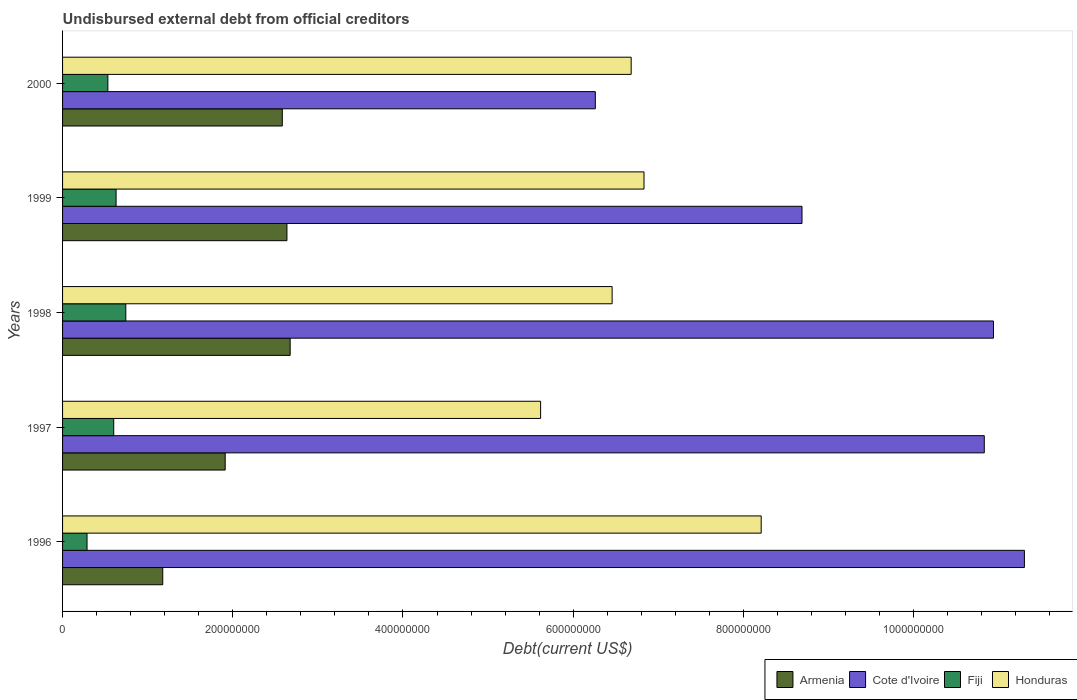Are the number of bars per tick equal to the number of legend labels?
Provide a succinct answer. Yes. Are the number of bars on each tick of the Y-axis equal?
Your answer should be very brief. Yes. How many bars are there on the 5th tick from the top?
Your answer should be compact. 4. How many bars are there on the 5th tick from the bottom?
Offer a terse response. 4. In how many cases, is the number of bars for a given year not equal to the number of legend labels?
Ensure brevity in your answer.  0. What is the total debt in Armenia in 2000?
Your response must be concise. 2.58e+08. Across all years, what is the maximum total debt in Cote d'Ivoire?
Your answer should be very brief. 1.13e+09. Across all years, what is the minimum total debt in Armenia?
Provide a succinct answer. 1.18e+08. In which year was the total debt in Honduras maximum?
Provide a short and direct response. 1996. What is the total total debt in Honduras in the graph?
Ensure brevity in your answer.  3.38e+09. What is the difference between the total debt in Armenia in 1998 and that in 1999?
Provide a succinct answer. 3.78e+06. What is the difference between the total debt in Fiji in 2000 and the total debt in Armenia in 1998?
Give a very brief answer. -2.14e+08. What is the average total debt in Armenia per year?
Your response must be concise. 2.20e+08. In the year 1998, what is the difference between the total debt in Honduras and total debt in Fiji?
Your answer should be very brief. 5.71e+08. In how many years, is the total debt in Cote d'Ivoire greater than 1080000000 US$?
Provide a succinct answer. 3. What is the ratio of the total debt in Armenia in 1997 to that in 1998?
Your answer should be compact. 0.71. Is the difference between the total debt in Honduras in 1997 and 1999 greater than the difference between the total debt in Fiji in 1997 and 1999?
Give a very brief answer. No. What is the difference between the highest and the second highest total debt in Honduras?
Keep it short and to the point. 1.38e+08. What is the difference between the highest and the lowest total debt in Cote d'Ivoire?
Provide a succinct answer. 5.04e+08. Is the sum of the total debt in Armenia in 1998 and 2000 greater than the maximum total debt in Cote d'Ivoire across all years?
Provide a short and direct response. No. What does the 1st bar from the top in 1999 represents?
Make the answer very short. Honduras. What does the 4th bar from the bottom in 1999 represents?
Provide a succinct answer. Honduras. Is it the case that in every year, the sum of the total debt in Fiji and total debt in Armenia is greater than the total debt in Honduras?
Offer a very short reply. No. How many years are there in the graph?
Provide a short and direct response. 5. Where does the legend appear in the graph?
Your answer should be very brief. Bottom right. How are the legend labels stacked?
Give a very brief answer. Horizontal. What is the title of the graph?
Your answer should be very brief. Undisbursed external debt from official creditors. What is the label or title of the X-axis?
Your answer should be compact. Debt(current US$). What is the Debt(current US$) in Armenia in 1996?
Your response must be concise. 1.18e+08. What is the Debt(current US$) in Cote d'Ivoire in 1996?
Your response must be concise. 1.13e+09. What is the Debt(current US$) of Fiji in 1996?
Your answer should be compact. 2.88e+07. What is the Debt(current US$) in Honduras in 1996?
Provide a short and direct response. 8.21e+08. What is the Debt(current US$) in Armenia in 1997?
Provide a short and direct response. 1.91e+08. What is the Debt(current US$) in Cote d'Ivoire in 1997?
Offer a terse response. 1.08e+09. What is the Debt(current US$) in Fiji in 1997?
Offer a very short reply. 6.01e+07. What is the Debt(current US$) of Honduras in 1997?
Offer a terse response. 5.62e+08. What is the Debt(current US$) of Armenia in 1998?
Provide a succinct answer. 2.67e+08. What is the Debt(current US$) of Cote d'Ivoire in 1998?
Your answer should be very brief. 1.09e+09. What is the Debt(current US$) of Fiji in 1998?
Make the answer very short. 7.43e+07. What is the Debt(current US$) of Honduras in 1998?
Provide a short and direct response. 6.46e+08. What is the Debt(current US$) in Armenia in 1999?
Your response must be concise. 2.64e+08. What is the Debt(current US$) in Cote d'Ivoire in 1999?
Ensure brevity in your answer.  8.69e+08. What is the Debt(current US$) in Fiji in 1999?
Your response must be concise. 6.29e+07. What is the Debt(current US$) in Honduras in 1999?
Ensure brevity in your answer.  6.83e+08. What is the Debt(current US$) of Armenia in 2000?
Offer a very short reply. 2.58e+08. What is the Debt(current US$) in Cote d'Ivoire in 2000?
Offer a terse response. 6.26e+08. What is the Debt(current US$) in Fiji in 2000?
Your answer should be very brief. 5.32e+07. What is the Debt(current US$) in Honduras in 2000?
Make the answer very short. 6.68e+08. Across all years, what is the maximum Debt(current US$) in Armenia?
Give a very brief answer. 2.67e+08. Across all years, what is the maximum Debt(current US$) in Cote d'Ivoire?
Provide a short and direct response. 1.13e+09. Across all years, what is the maximum Debt(current US$) of Fiji?
Ensure brevity in your answer.  7.43e+07. Across all years, what is the maximum Debt(current US$) of Honduras?
Your answer should be very brief. 8.21e+08. Across all years, what is the minimum Debt(current US$) of Armenia?
Offer a terse response. 1.18e+08. Across all years, what is the minimum Debt(current US$) of Cote d'Ivoire?
Your response must be concise. 6.26e+08. Across all years, what is the minimum Debt(current US$) in Fiji?
Make the answer very short. 2.88e+07. Across all years, what is the minimum Debt(current US$) in Honduras?
Keep it short and to the point. 5.62e+08. What is the total Debt(current US$) in Armenia in the graph?
Make the answer very short. 1.10e+09. What is the total Debt(current US$) of Cote d'Ivoire in the graph?
Make the answer very short. 4.80e+09. What is the total Debt(current US$) in Fiji in the graph?
Offer a very short reply. 2.79e+08. What is the total Debt(current US$) of Honduras in the graph?
Provide a short and direct response. 3.38e+09. What is the difference between the Debt(current US$) in Armenia in 1996 and that in 1997?
Your response must be concise. -7.34e+07. What is the difference between the Debt(current US$) in Cote d'Ivoire in 1996 and that in 1997?
Provide a short and direct response. 4.72e+07. What is the difference between the Debt(current US$) in Fiji in 1996 and that in 1997?
Your answer should be compact. -3.14e+07. What is the difference between the Debt(current US$) of Honduras in 1996 and that in 1997?
Keep it short and to the point. 2.59e+08. What is the difference between the Debt(current US$) in Armenia in 1996 and that in 1998?
Provide a short and direct response. -1.50e+08. What is the difference between the Debt(current US$) in Cote d'Ivoire in 1996 and that in 1998?
Your answer should be compact. 3.64e+07. What is the difference between the Debt(current US$) of Fiji in 1996 and that in 1998?
Offer a very short reply. -4.56e+07. What is the difference between the Debt(current US$) in Honduras in 1996 and that in 1998?
Offer a terse response. 1.75e+08. What is the difference between the Debt(current US$) in Armenia in 1996 and that in 1999?
Your response must be concise. -1.46e+08. What is the difference between the Debt(current US$) of Cote d'Ivoire in 1996 and that in 1999?
Make the answer very short. 2.61e+08. What is the difference between the Debt(current US$) in Fiji in 1996 and that in 1999?
Your response must be concise. -3.41e+07. What is the difference between the Debt(current US$) in Honduras in 1996 and that in 1999?
Make the answer very short. 1.38e+08. What is the difference between the Debt(current US$) in Armenia in 1996 and that in 2000?
Ensure brevity in your answer.  -1.40e+08. What is the difference between the Debt(current US$) in Cote d'Ivoire in 1996 and that in 2000?
Offer a very short reply. 5.04e+08. What is the difference between the Debt(current US$) of Fiji in 1996 and that in 2000?
Provide a short and direct response. -2.45e+07. What is the difference between the Debt(current US$) in Honduras in 1996 and that in 2000?
Your answer should be compact. 1.53e+08. What is the difference between the Debt(current US$) in Armenia in 1997 and that in 1998?
Provide a succinct answer. -7.63e+07. What is the difference between the Debt(current US$) in Cote d'Ivoire in 1997 and that in 1998?
Provide a short and direct response. -1.08e+07. What is the difference between the Debt(current US$) of Fiji in 1997 and that in 1998?
Offer a very short reply. -1.42e+07. What is the difference between the Debt(current US$) of Honduras in 1997 and that in 1998?
Offer a very short reply. -8.40e+07. What is the difference between the Debt(current US$) in Armenia in 1997 and that in 1999?
Offer a very short reply. -7.26e+07. What is the difference between the Debt(current US$) in Cote d'Ivoire in 1997 and that in 1999?
Your response must be concise. 2.14e+08. What is the difference between the Debt(current US$) in Fiji in 1997 and that in 1999?
Make the answer very short. -2.77e+06. What is the difference between the Debt(current US$) in Honduras in 1997 and that in 1999?
Provide a succinct answer. -1.22e+08. What is the difference between the Debt(current US$) in Armenia in 1997 and that in 2000?
Your response must be concise. -6.71e+07. What is the difference between the Debt(current US$) in Cote d'Ivoire in 1997 and that in 2000?
Keep it short and to the point. 4.57e+08. What is the difference between the Debt(current US$) in Fiji in 1997 and that in 2000?
Provide a succinct answer. 6.90e+06. What is the difference between the Debt(current US$) of Honduras in 1997 and that in 2000?
Your answer should be compact. -1.06e+08. What is the difference between the Debt(current US$) of Armenia in 1998 and that in 1999?
Your answer should be very brief. 3.78e+06. What is the difference between the Debt(current US$) in Cote d'Ivoire in 1998 and that in 1999?
Provide a succinct answer. 2.25e+08. What is the difference between the Debt(current US$) of Fiji in 1998 and that in 1999?
Your response must be concise. 1.14e+07. What is the difference between the Debt(current US$) of Honduras in 1998 and that in 1999?
Make the answer very short. -3.75e+07. What is the difference between the Debt(current US$) in Armenia in 1998 and that in 2000?
Your response must be concise. 9.23e+06. What is the difference between the Debt(current US$) of Cote d'Ivoire in 1998 and that in 2000?
Your answer should be compact. 4.68e+08. What is the difference between the Debt(current US$) of Fiji in 1998 and that in 2000?
Your response must be concise. 2.11e+07. What is the difference between the Debt(current US$) in Honduras in 1998 and that in 2000?
Offer a terse response. -2.24e+07. What is the difference between the Debt(current US$) of Armenia in 1999 and that in 2000?
Give a very brief answer. 5.45e+06. What is the difference between the Debt(current US$) of Cote d'Ivoire in 1999 and that in 2000?
Provide a short and direct response. 2.43e+08. What is the difference between the Debt(current US$) in Fiji in 1999 and that in 2000?
Your response must be concise. 9.67e+06. What is the difference between the Debt(current US$) of Honduras in 1999 and that in 2000?
Provide a succinct answer. 1.51e+07. What is the difference between the Debt(current US$) in Armenia in 1996 and the Debt(current US$) in Cote d'Ivoire in 1997?
Make the answer very short. -9.65e+08. What is the difference between the Debt(current US$) in Armenia in 1996 and the Debt(current US$) in Fiji in 1997?
Your response must be concise. 5.76e+07. What is the difference between the Debt(current US$) of Armenia in 1996 and the Debt(current US$) of Honduras in 1997?
Make the answer very short. -4.44e+08. What is the difference between the Debt(current US$) in Cote d'Ivoire in 1996 and the Debt(current US$) in Fiji in 1997?
Provide a succinct answer. 1.07e+09. What is the difference between the Debt(current US$) of Cote d'Ivoire in 1996 and the Debt(current US$) of Honduras in 1997?
Provide a succinct answer. 5.69e+08. What is the difference between the Debt(current US$) in Fiji in 1996 and the Debt(current US$) in Honduras in 1997?
Make the answer very short. -5.33e+08. What is the difference between the Debt(current US$) in Armenia in 1996 and the Debt(current US$) in Cote d'Ivoire in 1998?
Provide a short and direct response. -9.76e+08. What is the difference between the Debt(current US$) in Armenia in 1996 and the Debt(current US$) in Fiji in 1998?
Offer a very short reply. 4.34e+07. What is the difference between the Debt(current US$) in Armenia in 1996 and the Debt(current US$) in Honduras in 1998?
Your answer should be compact. -5.28e+08. What is the difference between the Debt(current US$) in Cote d'Ivoire in 1996 and the Debt(current US$) in Fiji in 1998?
Give a very brief answer. 1.06e+09. What is the difference between the Debt(current US$) of Cote d'Ivoire in 1996 and the Debt(current US$) of Honduras in 1998?
Provide a short and direct response. 4.84e+08. What is the difference between the Debt(current US$) in Fiji in 1996 and the Debt(current US$) in Honduras in 1998?
Provide a succinct answer. -6.17e+08. What is the difference between the Debt(current US$) in Armenia in 1996 and the Debt(current US$) in Cote d'Ivoire in 1999?
Offer a terse response. -7.51e+08. What is the difference between the Debt(current US$) of Armenia in 1996 and the Debt(current US$) of Fiji in 1999?
Your answer should be very brief. 5.48e+07. What is the difference between the Debt(current US$) in Armenia in 1996 and the Debt(current US$) in Honduras in 1999?
Provide a succinct answer. -5.66e+08. What is the difference between the Debt(current US$) in Cote d'Ivoire in 1996 and the Debt(current US$) in Fiji in 1999?
Your response must be concise. 1.07e+09. What is the difference between the Debt(current US$) in Cote d'Ivoire in 1996 and the Debt(current US$) in Honduras in 1999?
Provide a succinct answer. 4.47e+08. What is the difference between the Debt(current US$) in Fiji in 1996 and the Debt(current US$) in Honduras in 1999?
Your answer should be compact. -6.55e+08. What is the difference between the Debt(current US$) in Armenia in 1996 and the Debt(current US$) in Cote d'Ivoire in 2000?
Your answer should be very brief. -5.08e+08. What is the difference between the Debt(current US$) of Armenia in 1996 and the Debt(current US$) of Fiji in 2000?
Provide a succinct answer. 6.45e+07. What is the difference between the Debt(current US$) of Armenia in 1996 and the Debt(current US$) of Honduras in 2000?
Ensure brevity in your answer.  -5.50e+08. What is the difference between the Debt(current US$) of Cote d'Ivoire in 1996 and the Debt(current US$) of Fiji in 2000?
Provide a succinct answer. 1.08e+09. What is the difference between the Debt(current US$) of Cote d'Ivoire in 1996 and the Debt(current US$) of Honduras in 2000?
Your answer should be very brief. 4.62e+08. What is the difference between the Debt(current US$) of Fiji in 1996 and the Debt(current US$) of Honduras in 2000?
Keep it short and to the point. -6.39e+08. What is the difference between the Debt(current US$) in Armenia in 1997 and the Debt(current US$) in Cote d'Ivoire in 1998?
Your answer should be compact. -9.03e+08. What is the difference between the Debt(current US$) in Armenia in 1997 and the Debt(current US$) in Fiji in 1998?
Give a very brief answer. 1.17e+08. What is the difference between the Debt(current US$) in Armenia in 1997 and the Debt(current US$) in Honduras in 1998?
Provide a short and direct response. -4.55e+08. What is the difference between the Debt(current US$) in Cote d'Ivoire in 1997 and the Debt(current US$) in Fiji in 1998?
Your answer should be very brief. 1.01e+09. What is the difference between the Debt(current US$) in Cote d'Ivoire in 1997 and the Debt(current US$) in Honduras in 1998?
Provide a short and direct response. 4.37e+08. What is the difference between the Debt(current US$) in Fiji in 1997 and the Debt(current US$) in Honduras in 1998?
Your answer should be very brief. -5.86e+08. What is the difference between the Debt(current US$) in Armenia in 1997 and the Debt(current US$) in Cote d'Ivoire in 1999?
Keep it short and to the point. -6.78e+08. What is the difference between the Debt(current US$) in Armenia in 1997 and the Debt(current US$) in Fiji in 1999?
Your answer should be very brief. 1.28e+08. What is the difference between the Debt(current US$) in Armenia in 1997 and the Debt(current US$) in Honduras in 1999?
Your response must be concise. -4.92e+08. What is the difference between the Debt(current US$) of Cote d'Ivoire in 1997 and the Debt(current US$) of Fiji in 1999?
Keep it short and to the point. 1.02e+09. What is the difference between the Debt(current US$) of Cote d'Ivoire in 1997 and the Debt(current US$) of Honduras in 1999?
Your answer should be very brief. 4.00e+08. What is the difference between the Debt(current US$) of Fiji in 1997 and the Debt(current US$) of Honduras in 1999?
Keep it short and to the point. -6.23e+08. What is the difference between the Debt(current US$) in Armenia in 1997 and the Debt(current US$) in Cote d'Ivoire in 2000?
Provide a short and direct response. -4.35e+08. What is the difference between the Debt(current US$) in Armenia in 1997 and the Debt(current US$) in Fiji in 2000?
Offer a terse response. 1.38e+08. What is the difference between the Debt(current US$) in Armenia in 1997 and the Debt(current US$) in Honduras in 2000?
Your answer should be very brief. -4.77e+08. What is the difference between the Debt(current US$) in Cote d'Ivoire in 1997 and the Debt(current US$) in Fiji in 2000?
Your answer should be compact. 1.03e+09. What is the difference between the Debt(current US$) of Cote d'Ivoire in 1997 and the Debt(current US$) of Honduras in 2000?
Offer a very short reply. 4.15e+08. What is the difference between the Debt(current US$) of Fiji in 1997 and the Debt(current US$) of Honduras in 2000?
Offer a very short reply. -6.08e+08. What is the difference between the Debt(current US$) in Armenia in 1998 and the Debt(current US$) in Cote d'Ivoire in 1999?
Your answer should be very brief. -6.01e+08. What is the difference between the Debt(current US$) in Armenia in 1998 and the Debt(current US$) in Fiji in 1999?
Ensure brevity in your answer.  2.05e+08. What is the difference between the Debt(current US$) in Armenia in 1998 and the Debt(current US$) in Honduras in 1999?
Your response must be concise. -4.16e+08. What is the difference between the Debt(current US$) in Cote d'Ivoire in 1998 and the Debt(current US$) in Fiji in 1999?
Your response must be concise. 1.03e+09. What is the difference between the Debt(current US$) in Cote d'Ivoire in 1998 and the Debt(current US$) in Honduras in 1999?
Offer a very short reply. 4.11e+08. What is the difference between the Debt(current US$) in Fiji in 1998 and the Debt(current US$) in Honduras in 1999?
Your answer should be compact. -6.09e+08. What is the difference between the Debt(current US$) of Armenia in 1998 and the Debt(current US$) of Cote d'Ivoire in 2000?
Provide a succinct answer. -3.59e+08. What is the difference between the Debt(current US$) in Armenia in 1998 and the Debt(current US$) in Fiji in 2000?
Make the answer very short. 2.14e+08. What is the difference between the Debt(current US$) in Armenia in 1998 and the Debt(current US$) in Honduras in 2000?
Your answer should be very brief. -4.01e+08. What is the difference between the Debt(current US$) in Cote d'Ivoire in 1998 and the Debt(current US$) in Fiji in 2000?
Your answer should be compact. 1.04e+09. What is the difference between the Debt(current US$) of Cote d'Ivoire in 1998 and the Debt(current US$) of Honduras in 2000?
Keep it short and to the point. 4.26e+08. What is the difference between the Debt(current US$) in Fiji in 1998 and the Debt(current US$) in Honduras in 2000?
Your response must be concise. -5.94e+08. What is the difference between the Debt(current US$) of Armenia in 1999 and the Debt(current US$) of Cote d'Ivoire in 2000?
Your answer should be very brief. -3.62e+08. What is the difference between the Debt(current US$) of Armenia in 1999 and the Debt(current US$) of Fiji in 2000?
Provide a succinct answer. 2.10e+08. What is the difference between the Debt(current US$) of Armenia in 1999 and the Debt(current US$) of Honduras in 2000?
Provide a succinct answer. -4.05e+08. What is the difference between the Debt(current US$) of Cote d'Ivoire in 1999 and the Debt(current US$) of Fiji in 2000?
Your answer should be compact. 8.16e+08. What is the difference between the Debt(current US$) of Cote d'Ivoire in 1999 and the Debt(current US$) of Honduras in 2000?
Give a very brief answer. 2.01e+08. What is the difference between the Debt(current US$) of Fiji in 1999 and the Debt(current US$) of Honduras in 2000?
Your answer should be very brief. -6.05e+08. What is the average Debt(current US$) in Armenia per year?
Keep it short and to the point. 2.20e+08. What is the average Debt(current US$) of Cote d'Ivoire per year?
Ensure brevity in your answer.  9.60e+08. What is the average Debt(current US$) in Fiji per year?
Provide a short and direct response. 5.59e+07. What is the average Debt(current US$) of Honduras per year?
Provide a short and direct response. 6.76e+08. In the year 1996, what is the difference between the Debt(current US$) of Armenia and Debt(current US$) of Cote d'Ivoire?
Keep it short and to the point. -1.01e+09. In the year 1996, what is the difference between the Debt(current US$) in Armenia and Debt(current US$) in Fiji?
Your answer should be very brief. 8.90e+07. In the year 1996, what is the difference between the Debt(current US$) in Armenia and Debt(current US$) in Honduras?
Offer a terse response. -7.03e+08. In the year 1996, what is the difference between the Debt(current US$) in Cote d'Ivoire and Debt(current US$) in Fiji?
Your response must be concise. 1.10e+09. In the year 1996, what is the difference between the Debt(current US$) in Cote d'Ivoire and Debt(current US$) in Honduras?
Make the answer very short. 3.09e+08. In the year 1996, what is the difference between the Debt(current US$) in Fiji and Debt(current US$) in Honduras?
Provide a succinct answer. -7.92e+08. In the year 1997, what is the difference between the Debt(current US$) in Armenia and Debt(current US$) in Cote d'Ivoire?
Your answer should be compact. -8.92e+08. In the year 1997, what is the difference between the Debt(current US$) of Armenia and Debt(current US$) of Fiji?
Your response must be concise. 1.31e+08. In the year 1997, what is the difference between the Debt(current US$) in Armenia and Debt(current US$) in Honduras?
Your answer should be compact. -3.71e+08. In the year 1997, what is the difference between the Debt(current US$) in Cote d'Ivoire and Debt(current US$) in Fiji?
Your answer should be compact. 1.02e+09. In the year 1997, what is the difference between the Debt(current US$) in Cote d'Ivoire and Debt(current US$) in Honduras?
Provide a short and direct response. 5.21e+08. In the year 1997, what is the difference between the Debt(current US$) of Fiji and Debt(current US$) of Honduras?
Offer a terse response. -5.02e+08. In the year 1998, what is the difference between the Debt(current US$) of Armenia and Debt(current US$) of Cote d'Ivoire?
Offer a terse response. -8.26e+08. In the year 1998, what is the difference between the Debt(current US$) of Armenia and Debt(current US$) of Fiji?
Provide a succinct answer. 1.93e+08. In the year 1998, what is the difference between the Debt(current US$) of Armenia and Debt(current US$) of Honduras?
Provide a succinct answer. -3.78e+08. In the year 1998, what is the difference between the Debt(current US$) in Cote d'Ivoire and Debt(current US$) in Fiji?
Your answer should be very brief. 1.02e+09. In the year 1998, what is the difference between the Debt(current US$) of Cote d'Ivoire and Debt(current US$) of Honduras?
Offer a terse response. 4.48e+08. In the year 1998, what is the difference between the Debt(current US$) of Fiji and Debt(current US$) of Honduras?
Provide a succinct answer. -5.71e+08. In the year 1999, what is the difference between the Debt(current US$) of Armenia and Debt(current US$) of Cote d'Ivoire?
Make the answer very short. -6.05e+08. In the year 1999, what is the difference between the Debt(current US$) in Armenia and Debt(current US$) in Fiji?
Your response must be concise. 2.01e+08. In the year 1999, what is the difference between the Debt(current US$) in Armenia and Debt(current US$) in Honduras?
Keep it short and to the point. -4.20e+08. In the year 1999, what is the difference between the Debt(current US$) of Cote d'Ivoire and Debt(current US$) of Fiji?
Your answer should be compact. 8.06e+08. In the year 1999, what is the difference between the Debt(current US$) of Cote d'Ivoire and Debt(current US$) of Honduras?
Provide a short and direct response. 1.86e+08. In the year 1999, what is the difference between the Debt(current US$) in Fiji and Debt(current US$) in Honduras?
Your answer should be compact. -6.20e+08. In the year 2000, what is the difference between the Debt(current US$) in Armenia and Debt(current US$) in Cote d'Ivoire?
Provide a succinct answer. -3.68e+08. In the year 2000, what is the difference between the Debt(current US$) of Armenia and Debt(current US$) of Fiji?
Make the answer very short. 2.05e+08. In the year 2000, what is the difference between the Debt(current US$) in Armenia and Debt(current US$) in Honduras?
Make the answer very short. -4.10e+08. In the year 2000, what is the difference between the Debt(current US$) in Cote d'Ivoire and Debt(current US$) in Fiji?
Offer a terse response. 5.73e+08. In the year 2000, what is the difference between the Debt(current US$) in Cote d'Ivoire and Debt(current US$) in Honduras?
Keep it short and to the point. -4.21e+07. In the year 2000, what is the difference between the Debt(current US$) of Fiji and Debt(current US$) of Honduras?
Make the answer very short. -6.15e+08. What is the ratio of the Debt(current US$) in Armenia in 1996 to that in 1997?
Offer a very short reply. 0.62. What is the ratio of the Debt(current US$) in Cote d'Ivoire in 1996 to that in 1997?
Ensure brevity in your answer.  1.04. What is the ratio of the Debt(current US$) in Fiji in 1996 to that in 1997?
Your response must be concise. 0.48. What is the ratio of the Debt(current US$) in Honduras in 1996 to that in 1997?
Your answer should be compact. 1.46. What is the ratio of the Debt(current US$) of Armenia in 1996 to that in 1998?
Provide a succinct answer. 0.44. What is the ratio of the Debt(current US$) in Cote d'Ivoire in 1996 to that in 1998?
Make the answer very short. 1.03. What is the ratio of the Debt(current US$) in Fiji in 1996 to that in 1998?
Offer a terse response. 0.39. What is the ratio of the Debt(current US$) of Honduras in 1996 to that in 1998?
Provide a succinct answer. 1.27. What is the ratio of the Debt(current US$) of Armenia in 1996 to that in 1999?
Offer a very short reply. 0.45. What is the ratio of the Debt(current US$) in Cote d'Ivoire in 1996 to that in 1999?
Provide a succinct answer. 1.3. What is the ratio of the Debt(current US$) in Fiji in 1996 to that in 1999?
Offer a very short reply. 0.46. What is the ratio of the Debt(current US$) in Honduras in 1996 to that in 1999?
Make the answer very short. 1.2. What is the ratio of the Debt(current US$) of Armenia in 1996 to that in 2000?
Offer a terse response. 0.46. What is the ratio of the Debt(current US$) of Cote d'Ivoire in 1996 to that in 2000?
Offer a very short reply. 1.81. What is the ratio of the Debt(current US$) in Fiji in 1996 to that in 2000?
Provide a succinct answer. 0.54. What is the ratio of the Debt(current US$) in Honduras in 1996 to that in 2000?
Your answer should be compact. 1.23. What is the ratio of the Debt(current US$) of Armenia in 1997 to that in 1998?
Your answer should be very brief. 0.71. What is the ratio of the Debt(current US$) in Fiji in 1997 to that in 1998?
Ensure brevity in your answer.  0.81. What is the ratio of the Debt(current US$) of Honduras in 1997 to that in 1998?
Provide a short and direct response. 0.87. What is the ratio of the Debt(current US$) in Armenia in 1997 to that in 1999?
Your answer should be compact. 0.72. What is the ratio of the Debt(current US$) of Cote d'Ivoire in 1997 to that in 1999?
Give a very brief answer. 1.25. What is the ratio of the Debt(current US$) of Fiji in 1997 to that in 1999?
Keep it short and to the point. 0.96. What is the ratio of the Debt(current US$) of Honduras in 1997 to that in 1999?
Offer a very short reply. 0.82. What is the ratio of the Debt(current US$) in Armenia in 1997 to that in 2000?
Provide a succinct answer. 0.74. What is the ratio of the Debt(current US$) in Cote d'Ivoire in 1997 to that in 2000?
Offer a very short reply. 1.73. What is the ratio of the Debt(current US$) in Fiji in 1997 to that in 2000?
Provide a succinct answer. 1.13. What is the ratio of the Debt(current US$) in Honduras in 1997 to that in 2000?
Provide a short and direct response. 0.84. What is the ratio of the Debt(current US$) of Armenia in 1998 to that in 1999?
Offer a very short reply. 1.01. What is the ratio of the Debt(current US$) of Cote d'Ivoire in 1998 to that in 1999?
Offer a terse response. 1.26. What is the ratio of the Debt(current US$) of Fiji in 1998 to that in 1999?
Your response must be concise. 1.18. What is the ratio of the Debt(current US$) in Honduras in 1998 to that in 1999?
Provide a short and direct response. 0.95. What is the ratio of the Debt(current US$) in Armenia in 1998 to that in 2000?
Ensure brevity in your answer.  1.04. What is the ratio of the Debt(current US$) of Cote d'Ivoire in 1998 to that in 2000?
Ensure brevity in your answer.  1.75. What is the ratio of the Debt(current US$) of Fiji in 1998 to that in 2000?
Make the answer very short. 1.4. What is the ratio of the Debt(current US$) of Honduras in 1998 to that in 2000?
Your answer should be compact. 0.97. What is the ratio of the Debt(current US$) in Armenia in 1999 to that in 2000?
Your answer should be very brief. 1.02. What is the ratio of the Debt(current US$) of Cote d'Ivoire in 1999 to that in 2000?
Keep it short and to the point. 1.39. What is the ratio of the Debt(current US$) of Fiji in 1999 to that in 2000?
Your answer should be very brief. 1.18. What is the ratio of the Debt(current US$) of Honduras in 1999 to that in 2000?
Your response must be concise. 1.02. What is the difference between the highest and the second highest Debt(current US$) in Armenia?
Give a very brief answer. 3.78e+06. What is the difference between the highest and the second highest Debt(current US$) of Cote d'Ivoire?
Make the answer very short. 3.64e+07. What is the difference between the highest and the second highest Debt(current US$) of Fiji?
Offer a terse response. 1.14e+07. What is the difference between the highest and the second highest Debt(current US$) of Honduras?
Give a very brief answer. 1.38e+08. What is the difference between the highest and the lowest Debt(current US$) of Armenia?
Make the answer very short. 1.50e+08. What is the difference between the highest and the lowest Debt(current US$) of Cote d'Ivoire?
Your answer should be compact. 5.04e+08. What is the difference between the highest and the lowest Debt(current US$) of Fiji?
Offer a terse response. 4.56e+07. What is the difference between the highest and the lowest Debt(current US$) of Honduras?
Provide a short and direct response. 2.59e+08. 